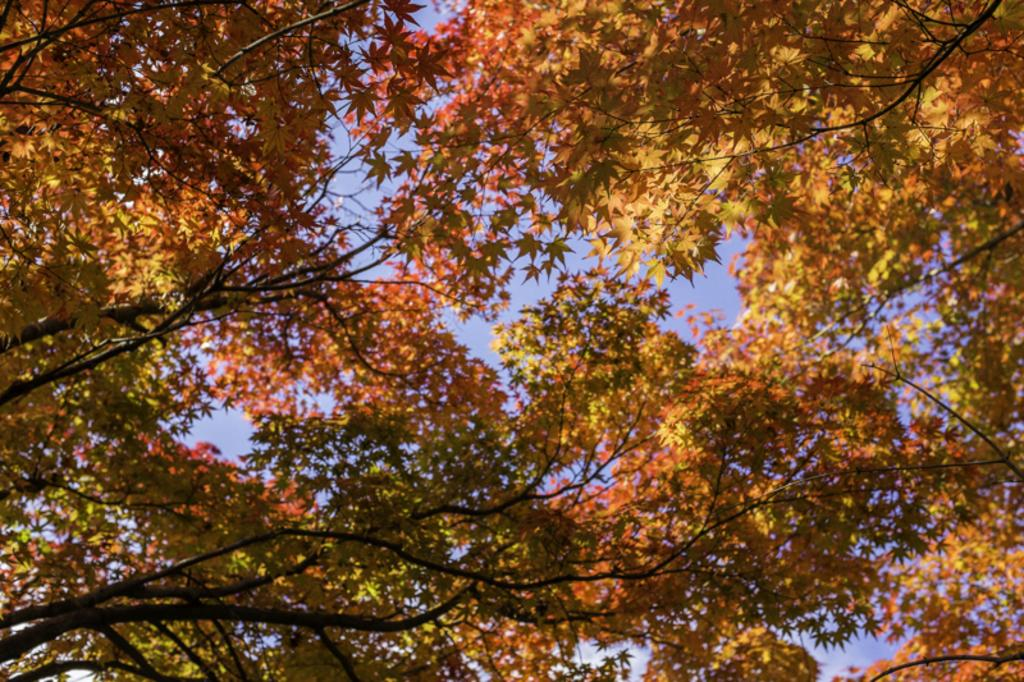What type of vegetation is present in the image? There are branches of a tree in the image. What part of the natural environment is visible in the image? The sky is visible in the image. What type of behavior can be observed in the room in the image? There is no room present in the image; it features branches of a tree and the sky. How many stars can be seen in the image? There is no star visible in the image; it only shows branches of a tree and the sky. 